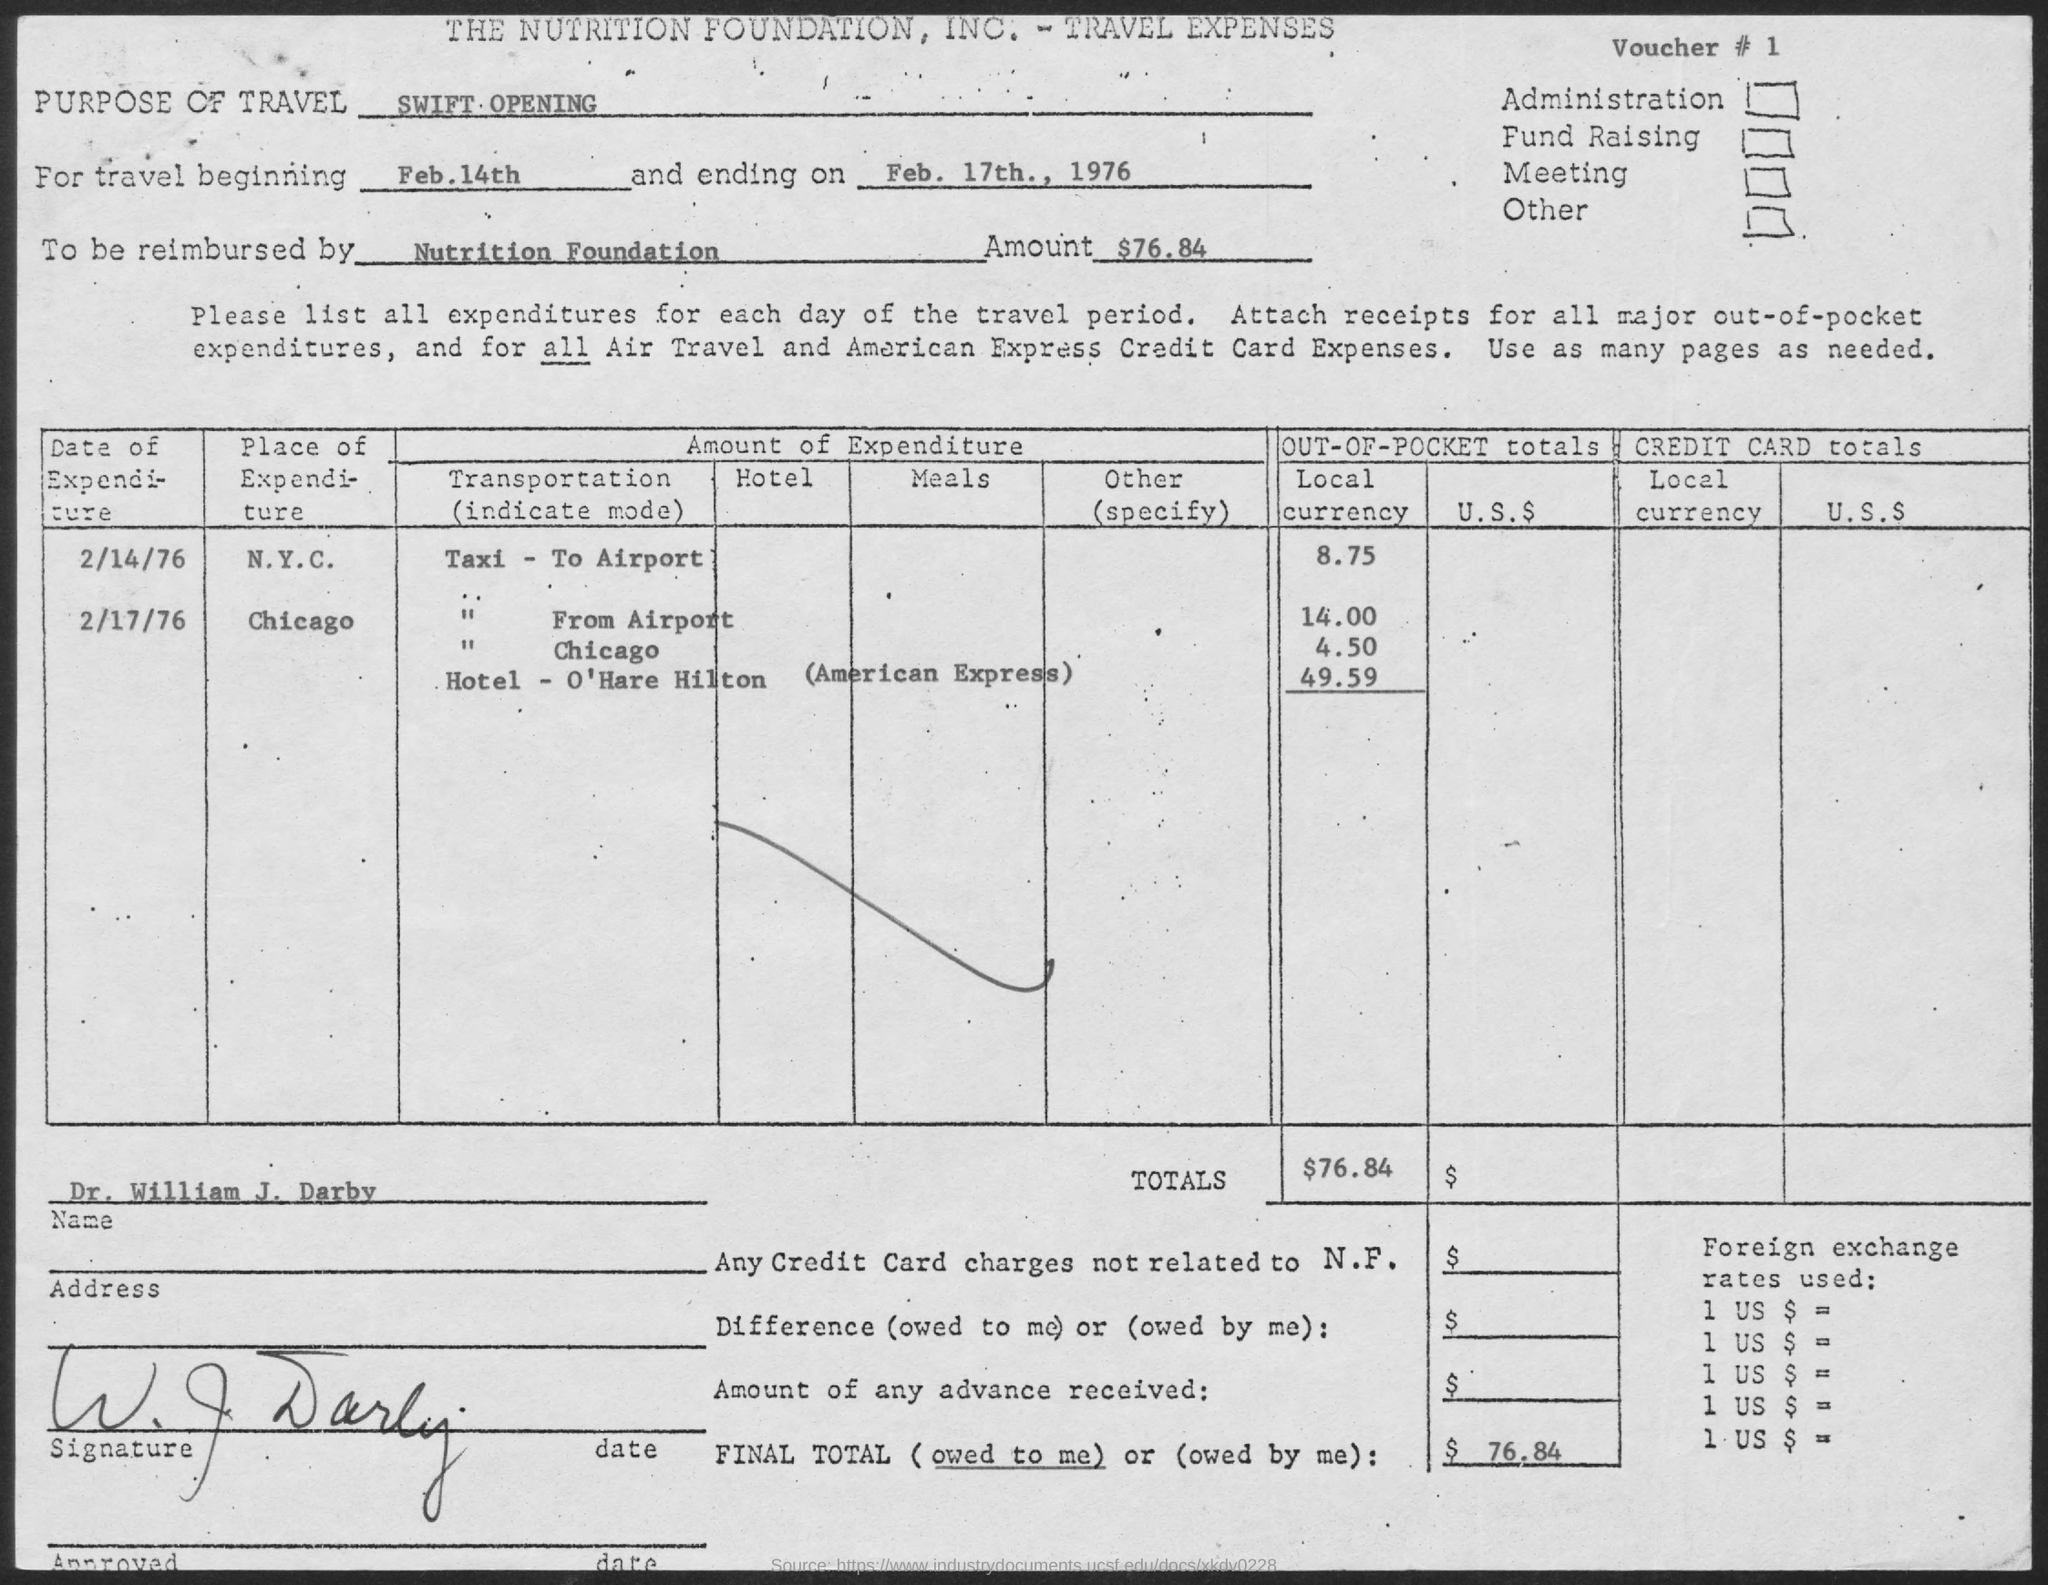Identify some key points in this picture. The travel ending date is February 17th, 1976. The travel journey will commence on February 14th. Please provide the voucher number, ranging from 1 to... 